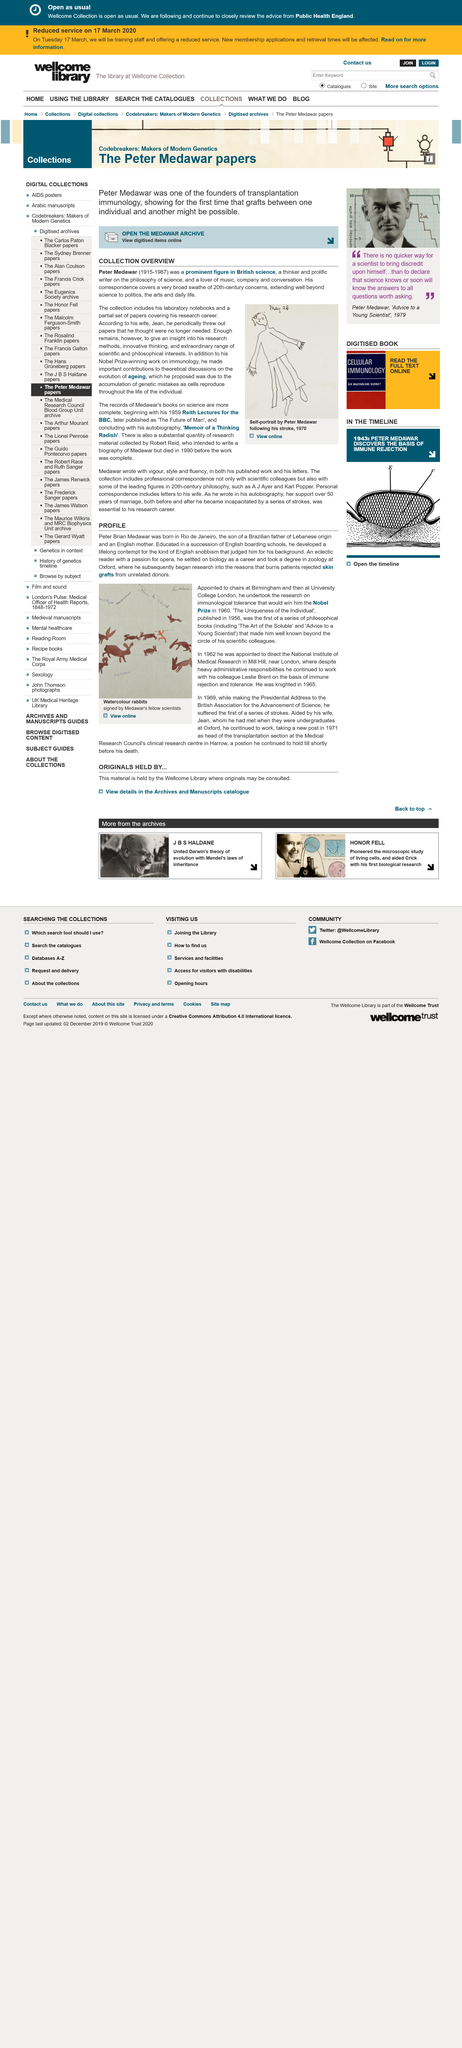Indicate a few pertinent items in this graphic. He conducted research at Oxford University, specifically focusing on the factors that cause burns patients to reject skin grafts from unrelated donors. He obtained a degree in Zoology from Oxford University. Peter Brian Medawar, a Brazilian-born scientist, was born in Rio de Janeiro. 